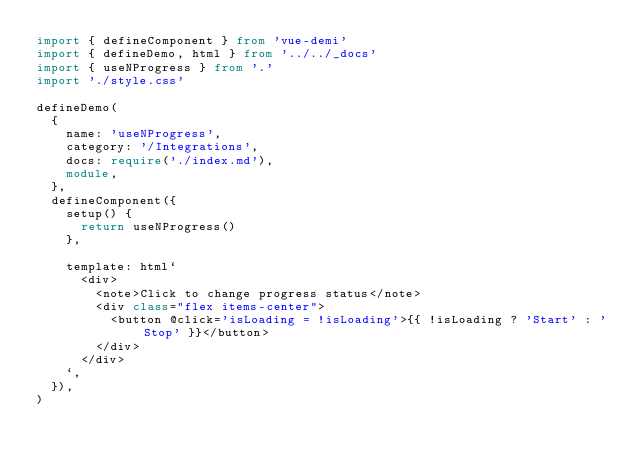<code> <loc_0><loc_0><loc_500><loc_500><_TypeScript_>import { defineComponent } from 'vue-demi'
import { defineDemo, html } from '../../_docs'
import { useNProgress } from '.'
import './style.css'

defineDemo(
  {
    name: 'useNProgress',
    category: '/Integrations',
    docs: require('./index.md'),
    module,
  },
  defineComponent({
    setup() {
      return useNProgress()
    },

    template: html`
      <div>
        <note>Click to change progress status</note>
        <div class="flex items-center">
          <button @click='isLoading = !isLoading'>{{ !isLoading ? 'Start' : 'Stop' }}</button>
        </div>
      </div>
    `,
  }),
)
</code> 